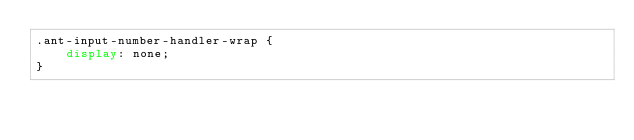Convert code to text. <code><loc_0><loc_0><loc_500><loc_500><_CSS_>.ant-input-number-handler-wrap {
    display: none;
}
</code> 